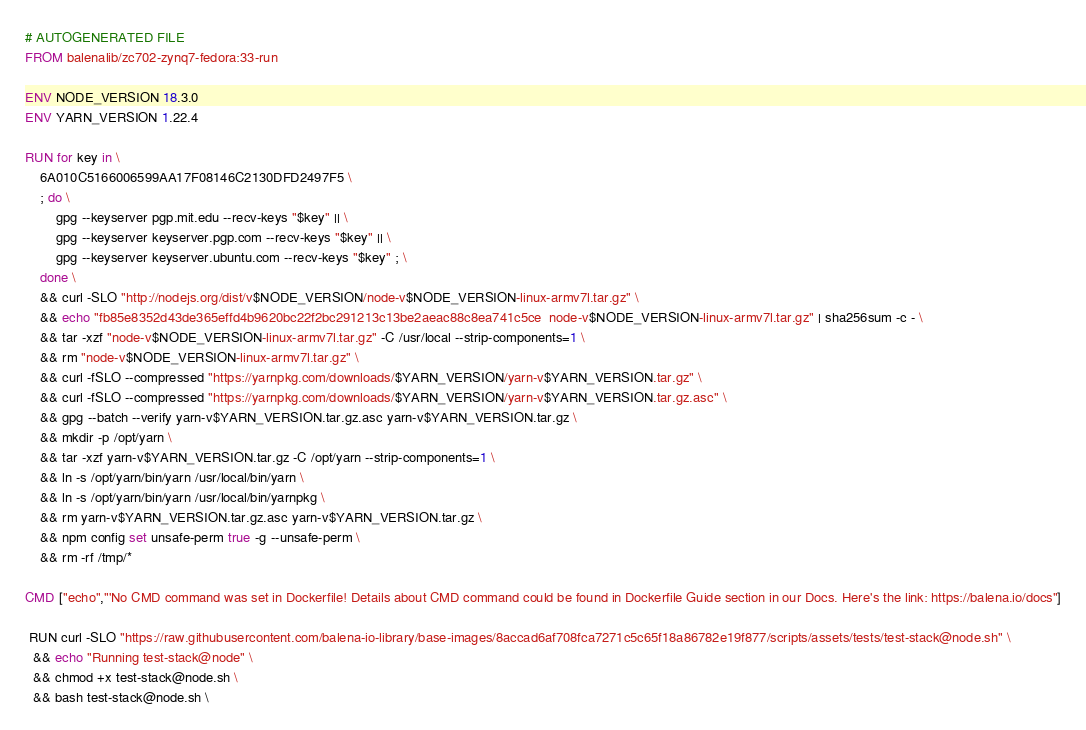Convert code to text. <code><loc_0><loc_0><loc_500><loc_500><_Dockerfile_># AUTOGENERATED FILE
FROM balenalib/zc702-zynq7-fedora:33-run

ENV NODE_VERSION 18.3.0
ENV YARN_VERSION 1.22.4

RUN for key in \
	6A010C5166006599AA17F08146C2130DFD2497F5 \
	; do \
		gpg --keyserver pgp.mit.edu --recv-keys "$key" || \
		gpg --keyserver keyserver.pgp.com --recv-keys "$key" || \
		gpg --keyserver keyserver.ubuntu.com --recv-keys "$key" ; \
	done \
	&& curl -SLO "http://nodejs.org/dist/v$NODE_VERSION/node-v$NODE_VERSION-linux-armv7l.tar.gz" \
	&& echo "fb85e8352d43de365effd4b9620bc22f2bc291213c13be2aeac88c8ea741c5ce  node-v$NODE_VERSION-linux-armv7l.tar.gz" | sha256sum -c - \
	&& tar -xzf "node-v$NODE_VERSION-linux-armv7l.tar.gz" -C /usr/local --strip-components=1 \
	&& rm "node-v$NODE_VERSION-linux-armv7l.tar.gz" \
	&& curl -fSLO --compressed "https://yarnpkg.com/downloads/$YARN_VERSION/yarn-v$YARN_VERSION.tar.gz" \
	&& curl -fSLO --compressed "https://yarnpkg.com/downloads/$YARN_VERSION/yarn-v$YARN_VERSION.tar.gz.asc" \
	&& gpg --batch --verify yarn-v$YARN_VERSION.tar.gz.asc yarn-v$YARN_VERSION.tar.gz \
	&& mkdir -p /opt/yarn \
	&& tar -xzf yarn-v$YARN_VERSION.tar.gz -C /opt/yarn --strip-components=1 \
	&& ln -s /opt/yarn/bin/yarn /usr/local/bin/yarn \
	&& ln -s /opt/yarn/bin/yarn /usr/local/bin/yarnpkg \
	&& rm yarn-v$YARN_VERSION.tar.gz.asc yarn-v$YARN_VERSION.tar.gz \
	&& npm config set unsafe-perm true -g --unsafe-perm \
	&& rm -rf /tmp/*

CMD ["echo","'No CMD command was set in Dockerfile! Details about CMD command could be found in Dockerfile Guide section in our Docs. Here's the link: https://balena.io/docs"]

 RUN curl -SLO "https://raw.githubusercontent.com/balena-io-library/base-images/8accad6af708fca7271c5c65f18a86782e19f877/scripts/assets/tests/test-stack@node.sh" \
  && echo "Running test-stack@node" \
  && chmod +x test-stack@node.sh \
  && bash test-stack@node.sh \</code> 